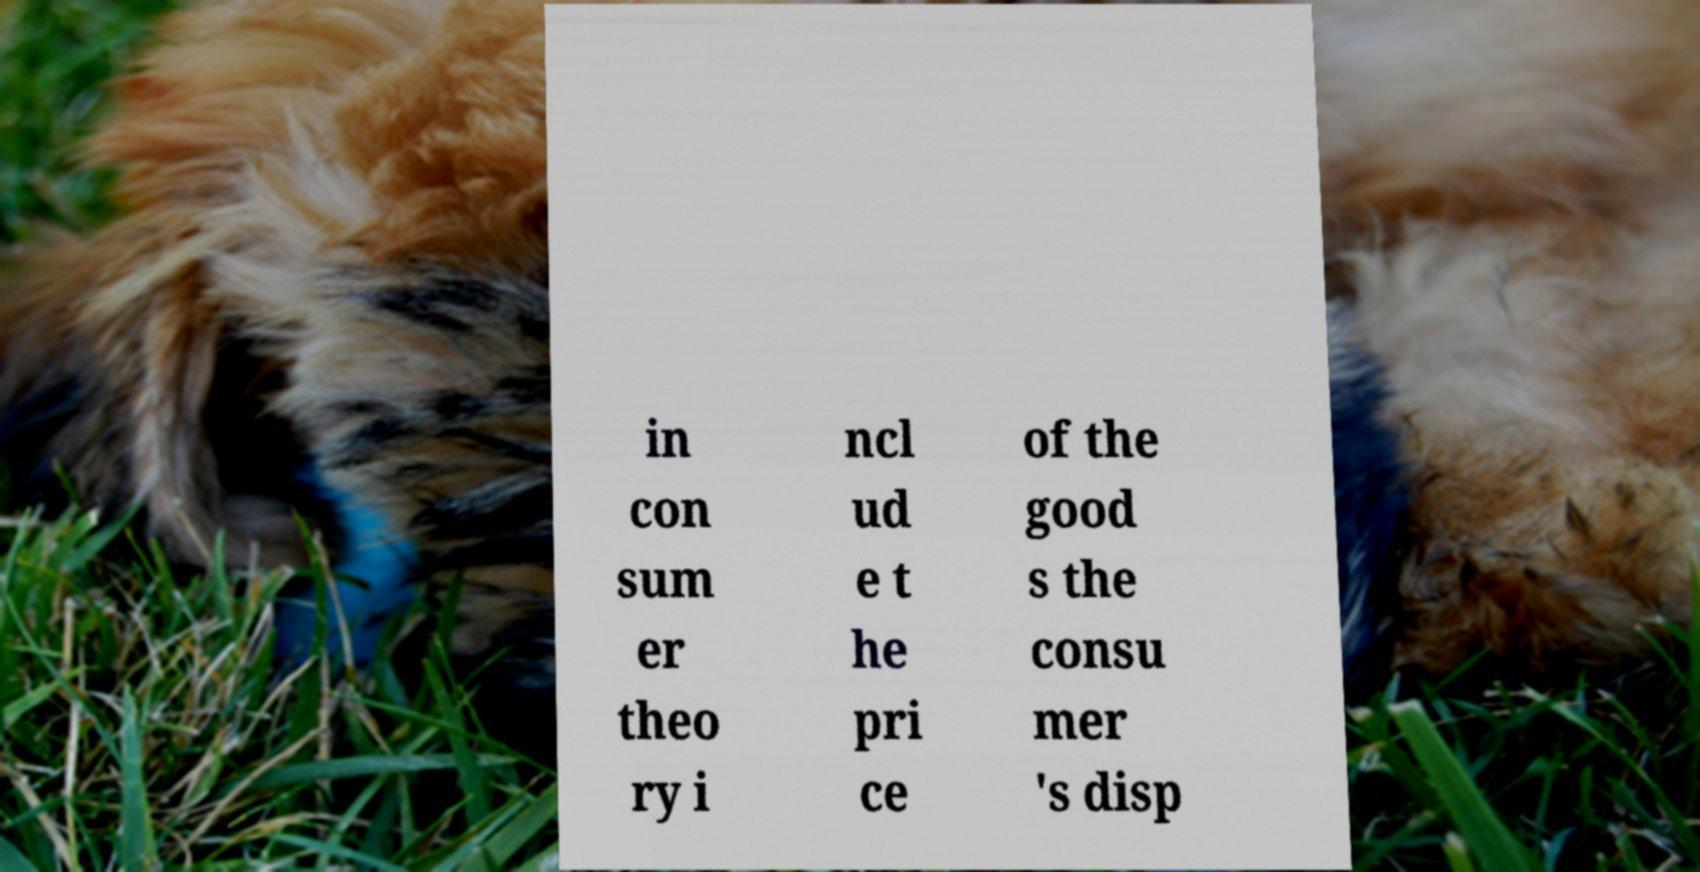Please read and relay the text visible in this image. What does it say? in con sum er theo ry i ncl ud e t he pri ce of the good s the consu mer 's disp 